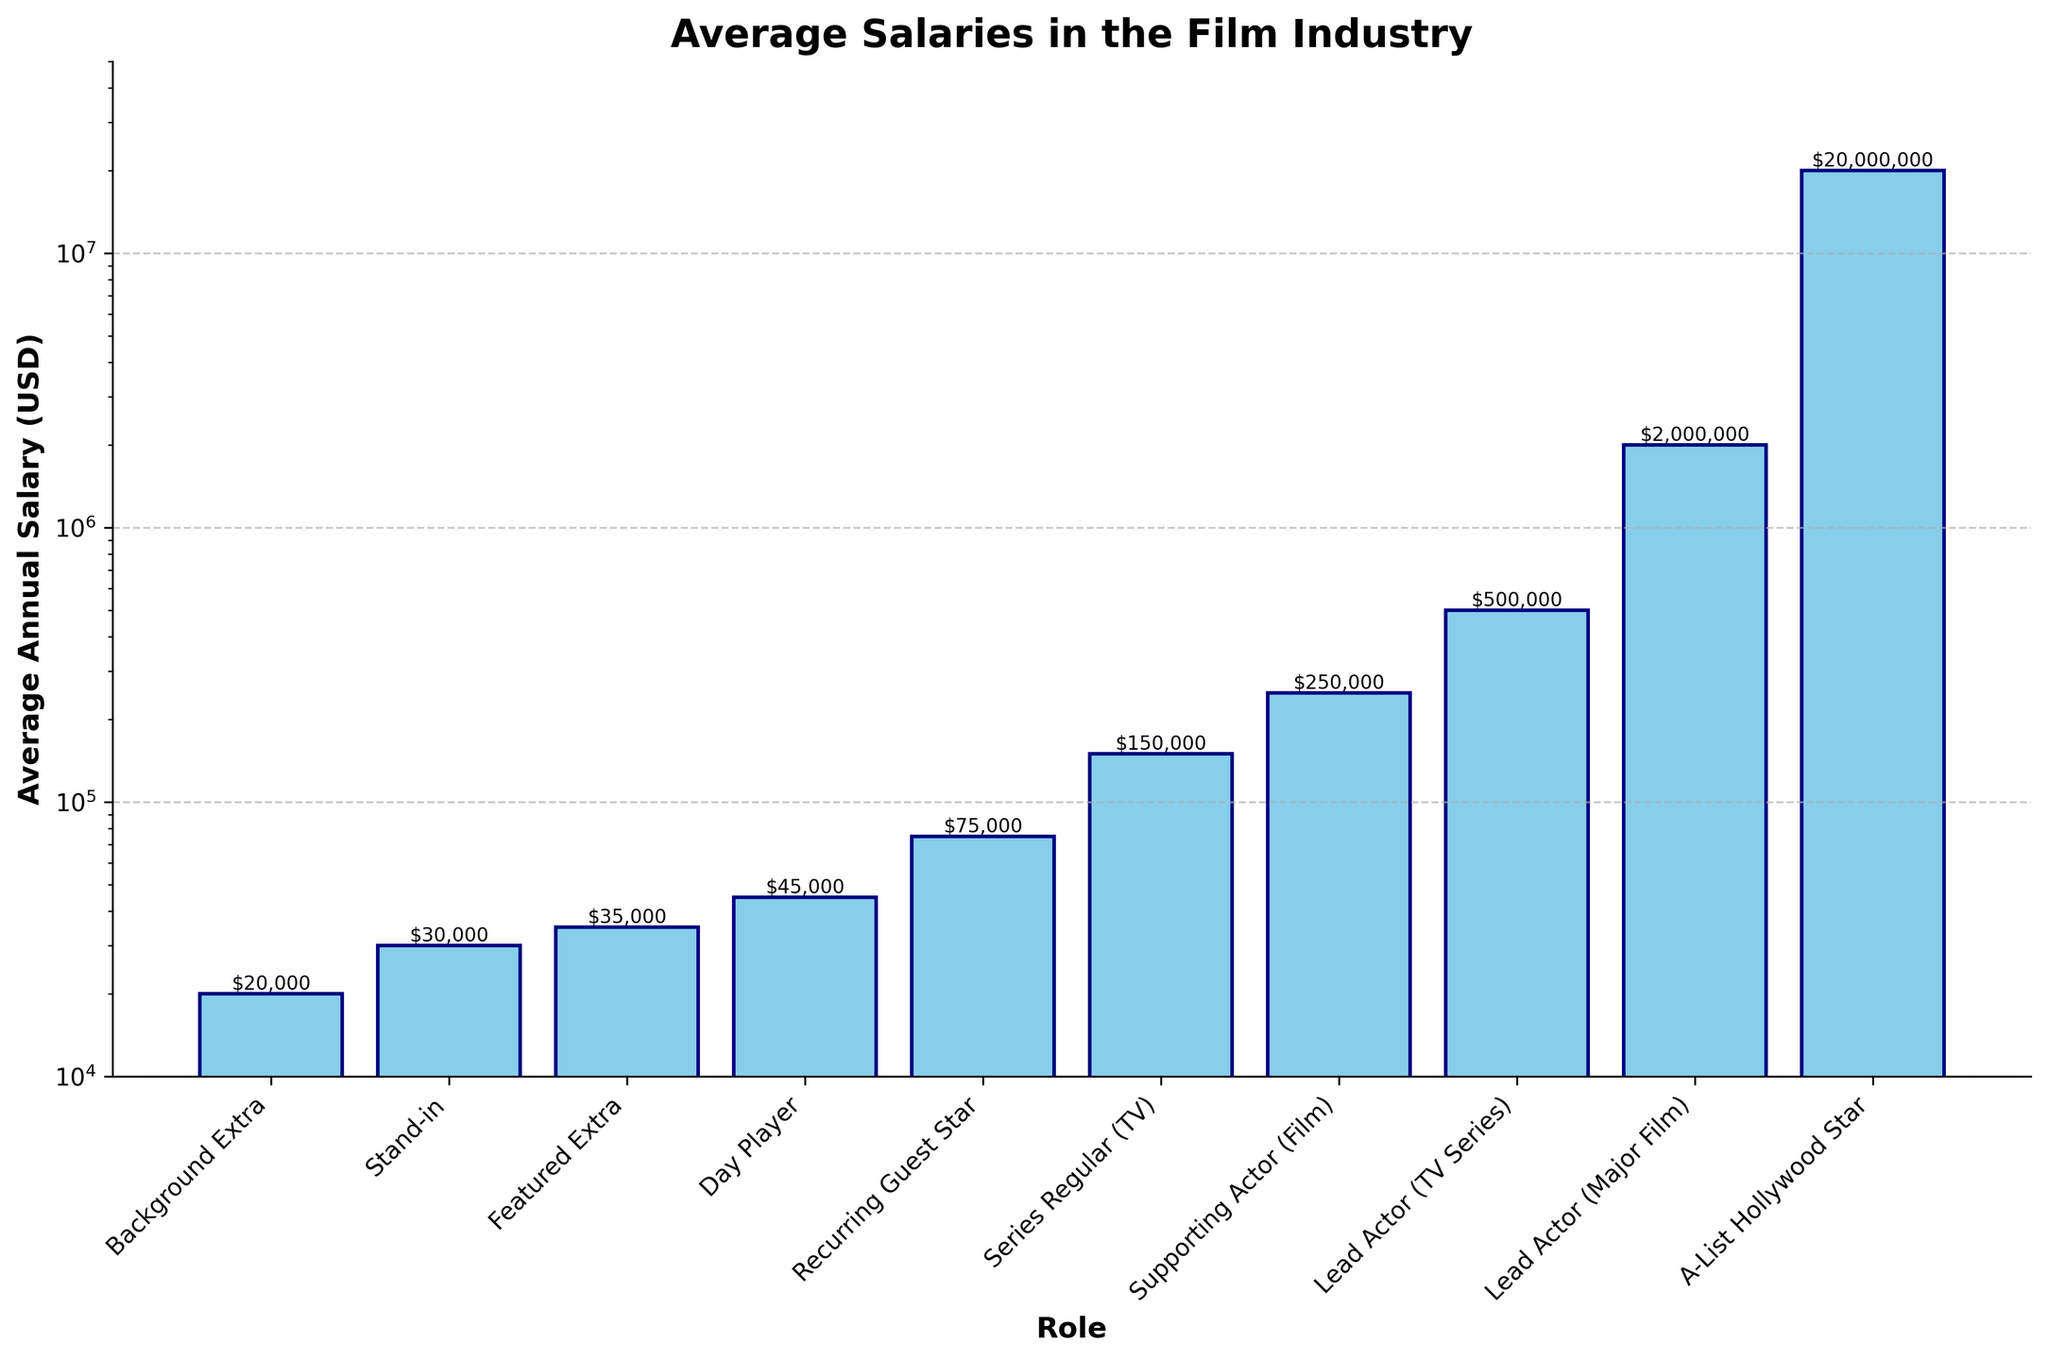What's the highest average annual salary among the roles listed? The bar for the "A-List Hollywood Star" role is the highest in the chart, reaching up to $20,000,000. Thus, the highest average annual salary among the roles is 20,000,000 USD.
Answer: $20,000,000 Which role has the lowest average annual salary? The shortest bar in the chart corresponds to the "Background Extra" role, indicating the lowest salary. Therefore, the "Background Extra" has the lowest average annual salary.
Answer: Background Extra What is the difference in average annual salary between a "Lead Actor (Major Film)" and a "Supporting Actor (Film)"? The average annual salary for a "Lead Actor (Major Film)" is $2,000,000, while for a "Supporting Actor (Film)" it is $250,000. The difference is $2,000,000 - $250,000 = $1,750,000.
Answer: $1,750,000 How many times larger is the salary of an "A-List Hollywood Star" compared to a "Day Player"? The salary of an "A-List Hollywood Star" is $20,000,000 and that of a "Day Player" is $45,000. The ratio is $20,000,000 / $45,000, which is approximately 444.44 times larger.
Answer: 444.44 Is the average annual salary of a "Series Regular (TV)" greater than that of a "Recurring Guest Star"? If so, by how much? The "Series Regular (TV)" earns $150,000, whereas the "Recurring Guest Star" earns $75,000. Therefore, the "Series Regular (TV)" earns $150,000 - $75,000 = $75,000 more.
Answer: Yes, $75,000 What's the combined average annual salary of a "Stand-in" and a "Featured Extra"? The average annual salary of a "Stand-in" is $30,000, and for a "Featured Extra" it is $35,000. The combined salary is $30,000 + $35,000 = $65,000.
Answer: $65,000 Which roles have an average annual salary of less than $100,000? The bars that fall below the $100,000 mark include "Background Extra" ($20,000), "Stand-in" ($30,000), "Featured Extra" ($35,000), "Day Player" ($45,000), and "Recurring Guest Star" ($75,000).
Answer: Background Extra, Stand-in, Featured Extra, Day Player, Recurring Guest Star What is the median average annual salary among all the roles listed? To find the median, list all the salaries in ascending order: 20000, 30000, 35000, 45000, 75000, 150000, 250000, 500000, 2000000, 20000000. The median is the middle value of this ordered list. Since there are 10 values, the median is the average of the 5th and 6th values: (75000 + 150000) / 2 = 112500.
Answer: $112,500 